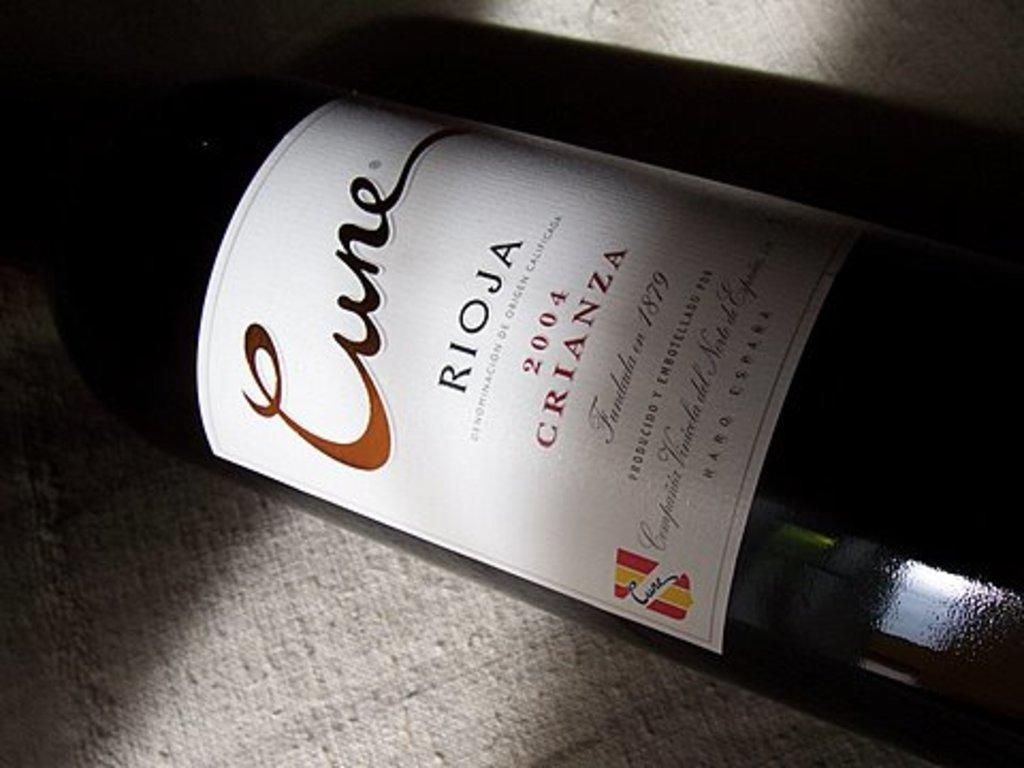<image>
Offer a succinct explanation of the picture presented. A bottle of wine with the word Rioja written on a white label. 